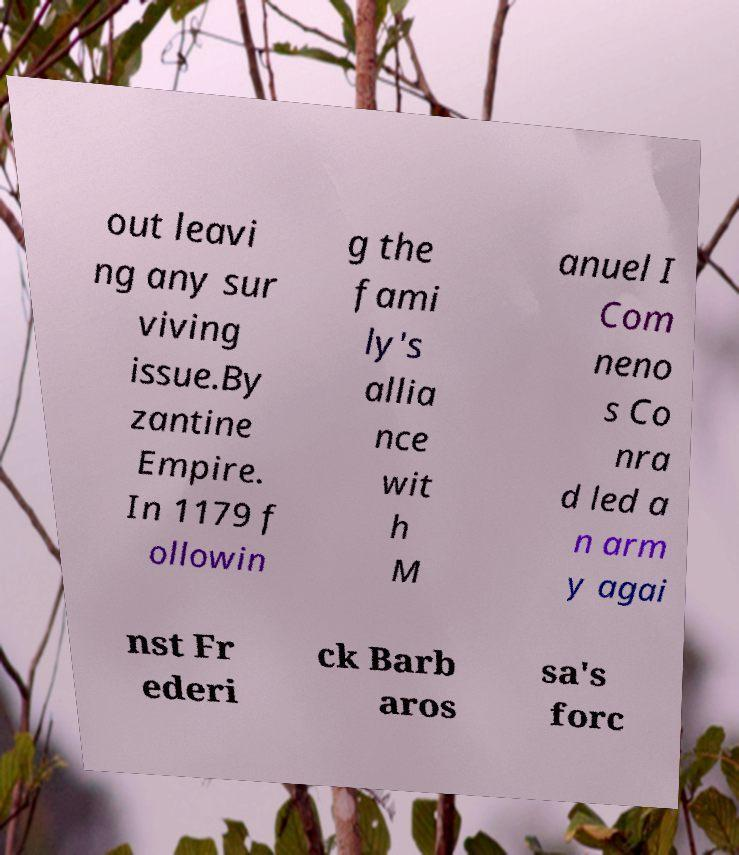Can you read and provide the text displayed in the image?This photo seems to have some interesting text. Can you extract and type it out for me? out leavi ng any sur viving issue.By zantine Empire. In 1179 f ollowin g the fami ly's allia nce wit h M anuel I Com neno s Co nra d led a n arm y agai nst Fr ederi ck Barb aros sa's forc 